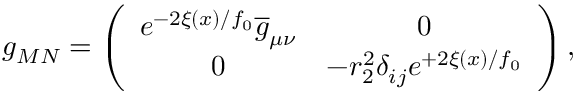<formula> <loc_0><loc_0><loc_500><loc_500>g _ { M N } = \left ( \begin{array} { c c } { { e ^ { - 2 \xi ( x ) / f _ { 0 } } \overline { g } _ { \mu \nu } } } & { 0 } \\ { 0 } & { { - r _ { 2 } ^ { 2 } \delta _ { i j } e ^ { + 2 \xi ( x ) / f _ { 0 } } } } \end{array} \right ) ,</formula> 